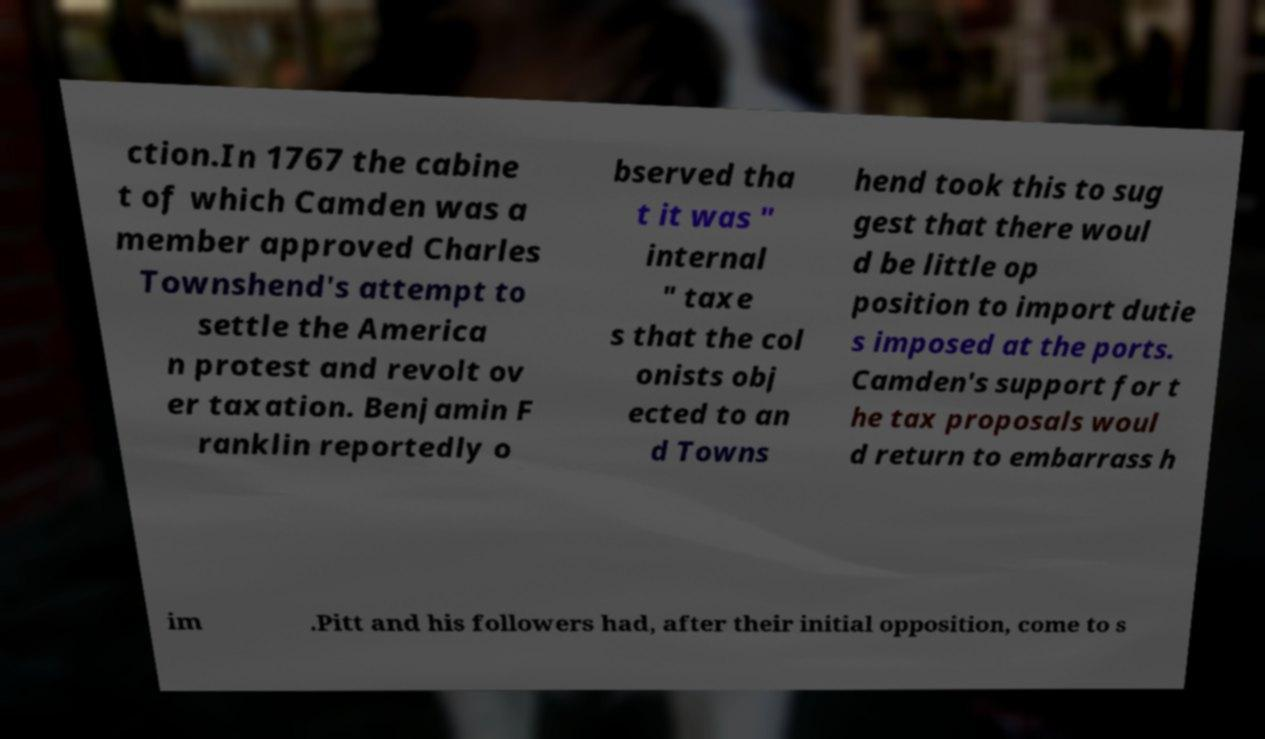Can you read and provide the text displayed in the image?This photo seems to have some interesting text. Can you extract and type it out for me? ction.In 1767 the cabine t of which Camden was a member approved Charles Townshend's attempt to settle the America n protest and revolt ov er taxation. Benjamin F ranklin reportedly o bserved tha t it was " internal " taxe s that the col onists obj ected to an d Towns hend took this to sug gest that there woul d be little op position to import dutie s imposed at the ports. Camden's support for t he tax proposals woul d return to embarrass h im .Pitt and his followers had, after their initial opposition, come to s 